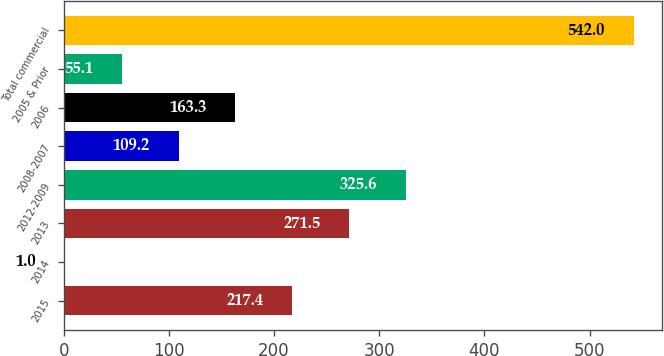<chart> <loc_0><loc_0><loc_500><loc_500><bar_chart><fcel>2015<fcel>2014<fcel>2013<fcel>2012-2009<fcel>2008-2007<fcel>2006<fcel>2005 & Prior<fcel>Total commercial<nl><fcel>217.4<fcel>1<fcel>271.5<fcel>325.6<fcel>109.2<fcel>163.3<fcel>55.1<fcel>542<nl></chart> 